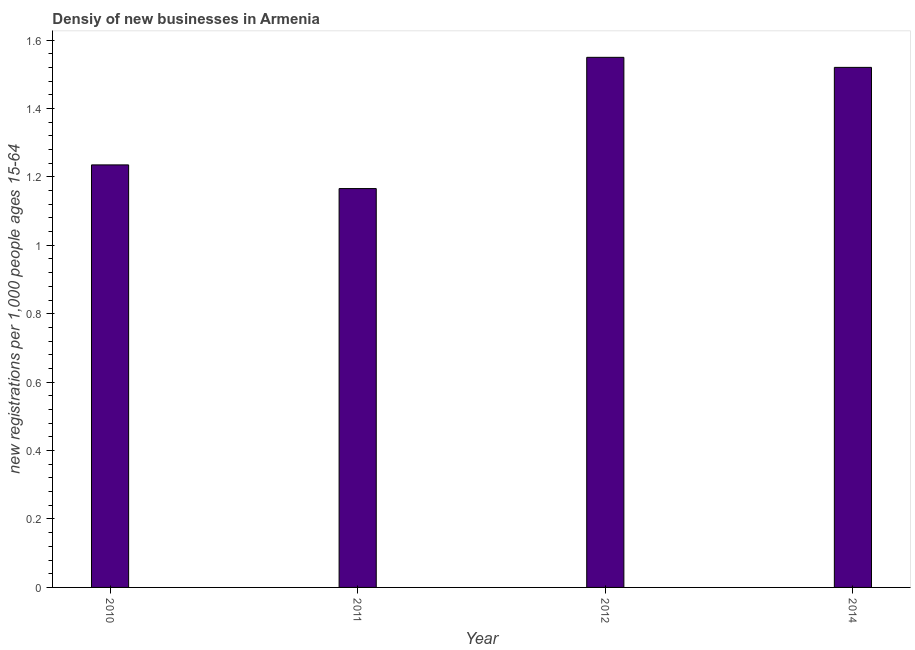Does the graph contain grids?
Ensure brevity in your answer.  No. What is the title of the graph?
Make the answer very short. Densiy of new businesses in Armenia. What is the label or title of the Y-axis?
Keep it short and to the point. New registrations per 1,0 people ages 15-64. What is the density of new business in 2010?
Ensure brevity in your answer.  1.23. Across all years, what is the maximum density of new business?
Your answer should be compact. 1.55. Across all years, what is the minimum density of new business?
Your response must be concise. 1.17. In which year was the density of new business minimum?
Your response must be concise. 2011. What is the sum of the density of new business?
Provide a succinct answer. 5.47. What is the difference between the density of new business in 2012 and 2014?
Your response must be concise. 0.03. What is the average density of new business per year?
Give a very brief answer. 1.37. What is the median density of new business?
Keep it short and to the point. 1.38. What is the ratio of the density of new business in 2011 to that in 2014?
Offer a very short reply. 0.77. Is the difference between the density of new business in 2011 and 2012 greater than the difference between any two years?
Provide a succinct answer. Yes. What is the difference between the highest and the second highest density of new business?
Offer a very short reply. 0.03. What is the difference between the highest and the lowest density of new business?
Your answer should be compact. 0.38. How many years are there in the graph?
Offer a terse response. 4. What is the difference between two consecutive major ticks on the Y-axis?
Give a very brief answer. 0.2. What is the new registrations per 1,000 people ages 15-64 of 2010?
Offer a terse response. 1.23. What is the new registrations per 1,000 people ages 15-64 of 2011?
Ensure brevity in your answer.  1.17. What is the new registrations per 1,000 people ages 15-64 in 2012?
Provide a succinct answer. 1.55. What is the new registrations per 1,000 people ages 15-64 of 2014?
Provide a succinct answer. 1.52. What is the difference between the new registrations per 1,000 people ages 15-64 in 2010 and 2011?
Ensure brevity in your answer.  0.07. What is the difference between the new registrations per 1,000 people ages 15-64 in 2010 and 2012?
Ensure brevity in your answer.  -0.31. What is the difference between the new registrations per 1,000 people ages 15-64 in 2010 and 2014?
Your answer should be very brief. -0.29. What is the difference between the new registrations per 1,000 people ages 15-64 in 2011 and 2012?
Your answer should be compact. -0.38. What is the difference between the new registrations per 1,000 people ages 15-64 in 2011 and 2014?
Give a very brief answer. -0.35. What is the difference between the new registrations per 1,000 people ages 15-64 in 2012 and 2014?
Give a very brief answer. 0.03. What is the ratio of the new registrations per 1,000 people ages 15-64 in 2010 to that in 2011?
Your answer should be very brief. 1.06. What is the ratio of the new registrations per 1,000 people ages 15-64 in 2010 to that in 2012?
Keep it short and to the point. 0.8. What is the ratio of the new registrations per 1,000 people ages 15-64 in 2010 to that in 2014?
Offer a very short reply. 0.81. What is the ratio of the new registrations per 1,000 people ages 15-64 in 2011 to that in 2012?
Ensure brevity in your answer.  0.75. What is the ratio of the new registrations per 1,000 people ages 15-64 in 2011 to that in 2014?
Ensure brevity in your answer.  0.77. 